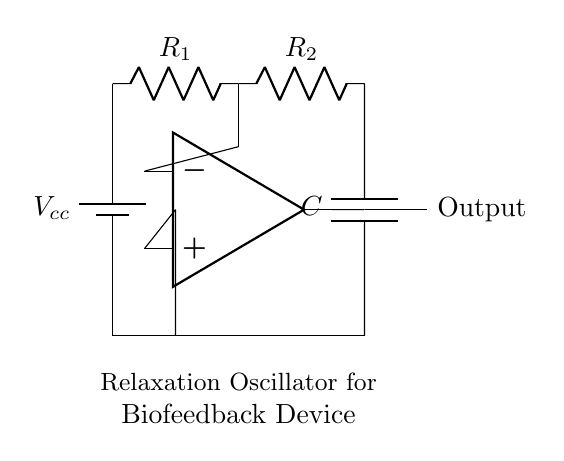What components are in the circuit? The circuit includes a battery, two resistors, a capacitor, and an operational amplifier. Each component plays a crucial role in creating the oscillation needed for biofeedback.
Answer: battery, resistors, capacitor, operational amplifier What is the purpose of the capacitor in this circuit? The capacitor stores and releases electrical energy, which helps create the timing necessary for the relaxation oscillator's oscillation process. The charge and discharge of the capacitor affect the frequency of the oscillation.
Answer: timing How many resistors are present in the circuit? There are two resistors labeled R1 and R2 in the circuit diagram, contributing to the feedback mechanism needed for oscillation.
Answer: two What kind of oscillator is represented in this circuit? This is a relaxation oscillator, which is characterized by the charging and discharging of a capacitor through resistors, often used in applications like biofeedback devices.
Answer: relaxation oscillator What does the output signify in this circuit? The output from the operational amplifier indicates the oscillation signal generated by the circuit, which can be utilized in stress management counseling to provide biofeedback to the user.
Answer: oscillation signal What is the connection type of the capacitor in relation to the resistors? The capacitor is connected in parallel to the two resistors, allowing it to charge through them and influencing the oscillation time period by their combined resistance.
Answer: parallel What happens at the output of the operational amplifier? The output will generate a square wave signal as the operational amplifier alternates between high and low states, depending on the capacitor's charging and discharging cycle.
Answer: square wave signal 